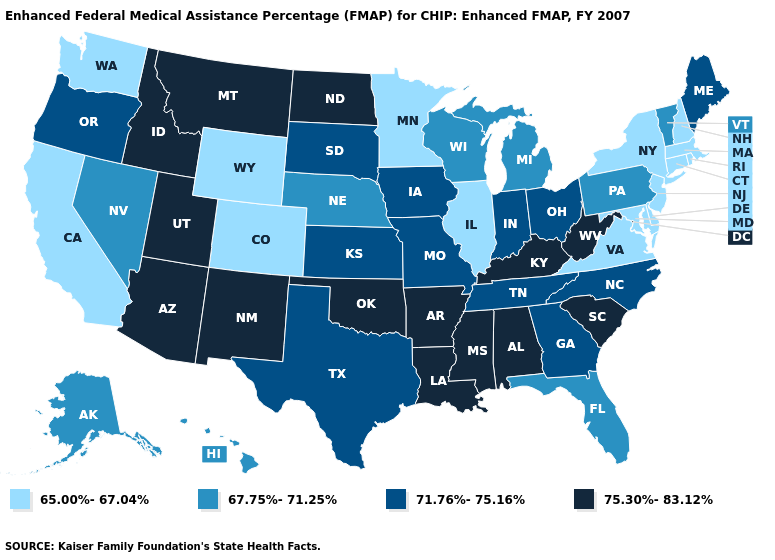What is the value of Tennessee?
Short answer required. 71.76%-75.16%. Name the states that have a value in the range 71.76%-75.16%?
Concise answer only. Georgia, Indiana, Iowa, Kansas, Maine, Missouri, North Carolina, Ohio, Oregon, South Dakota, Tennessee, Texas. What is the value of Rhode Island?
Be succinct. 65.00%-67.04%. Which states hav the highest value in the West?
Be succinct. Arizona, Idaho, Montana, New Mexico, Utah. Does the map have missing data?
Write a very short answer. No. Which states have the highest value in the USA?
Be succinct. Alabama, Arizona, Arkansas, Idaho, Kentucky, Louisiana, Mississippi, Montana, New Mexico, North Dakota, Oklahoma, South Carolina, Utah, West Virginia. Name the states that have a value in the range 75.30%-83.12%?
Answer briefly. Alabama, Arizona, Arkansas, Idaho, Kentucky, Louisiana, Mississippi, Montana, New Mexico, North Dakota, Oklahoma, South Carolina, Utah, West Virginia. Does Maryland have the highest value in the USA?
Be succinct. No. Does California have the same value as Utah?
Quick response, please. No. Name the states that have a value in the range 71.76%-75.16%?
Short answer required. Georgia, Indiana, Iowa, Kansas, Maine, Missouri, North Carolina, Ohio, Oregon, South Dakota, Tennessee, Texas. Name the states that have a value in the range 67.75%-71.25%?
Write a very short answer. Alaska, Florida, Hawaii, Michigan, Nebraska, Nevada, Pennsylvania, Vermont, Wisconsin. Does Arizona have the highest value in the USA?
Quick response, please. Yes. How many symbols are there in the legend?
Write a very short answer. 4. Name the states that have a value in the range 75.30%-83.12%?
Be succinct. Alabama, Arizona, Arkansas, Idaho, Kentucky, Louisiana, Mississippi, Montana, New Mexico, North Dakota, Oklahoma, South Carolina, Utah, West Virginia. What is the value of Texas?
Concise answer only. 71.76%-75.16%. 